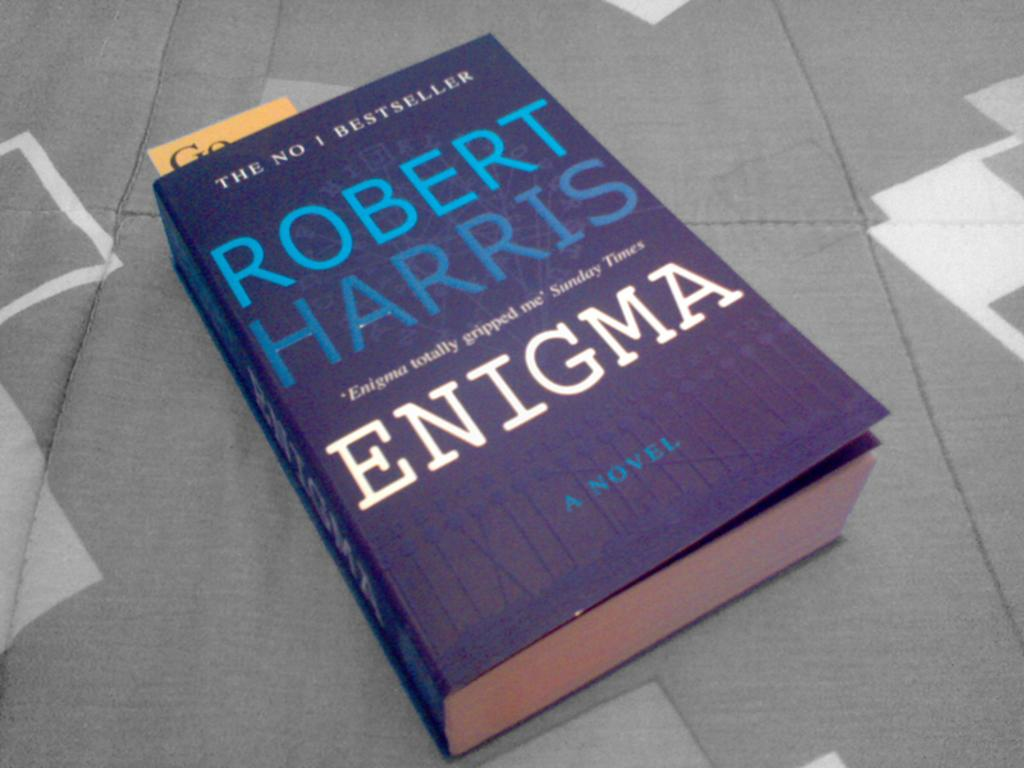<image>
Write a terse but informative summary of the picture. A copy of the book Enigma by Robert Harris. 